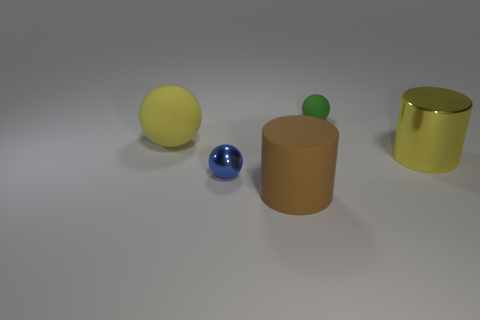Subtract all tiny rubber spheres. How many spheres are left? 2 Add 2 small brown matte objects. How many objects exist? 7 Subtract all blue spheres. How many spheres are left? 2 Subtract all cylinders. How many objects are left? 3 Subtract all small things. Subtract all yellow metal cylinders. How many objects are left? 2 Add 5 tiny green rubber balls. How many tiny green rubber balls are left? 6 Add 5 large gray rubber cylinders. How many large gray rubber cylinders exist? 5 Subtract 0 blue blocks. How many objects are left? 5 Subtract 1 cylinders. How many cylinders are left? 1 Subtract all brown spheres. Subtract all gray blocks. How many spheres are left? 3 